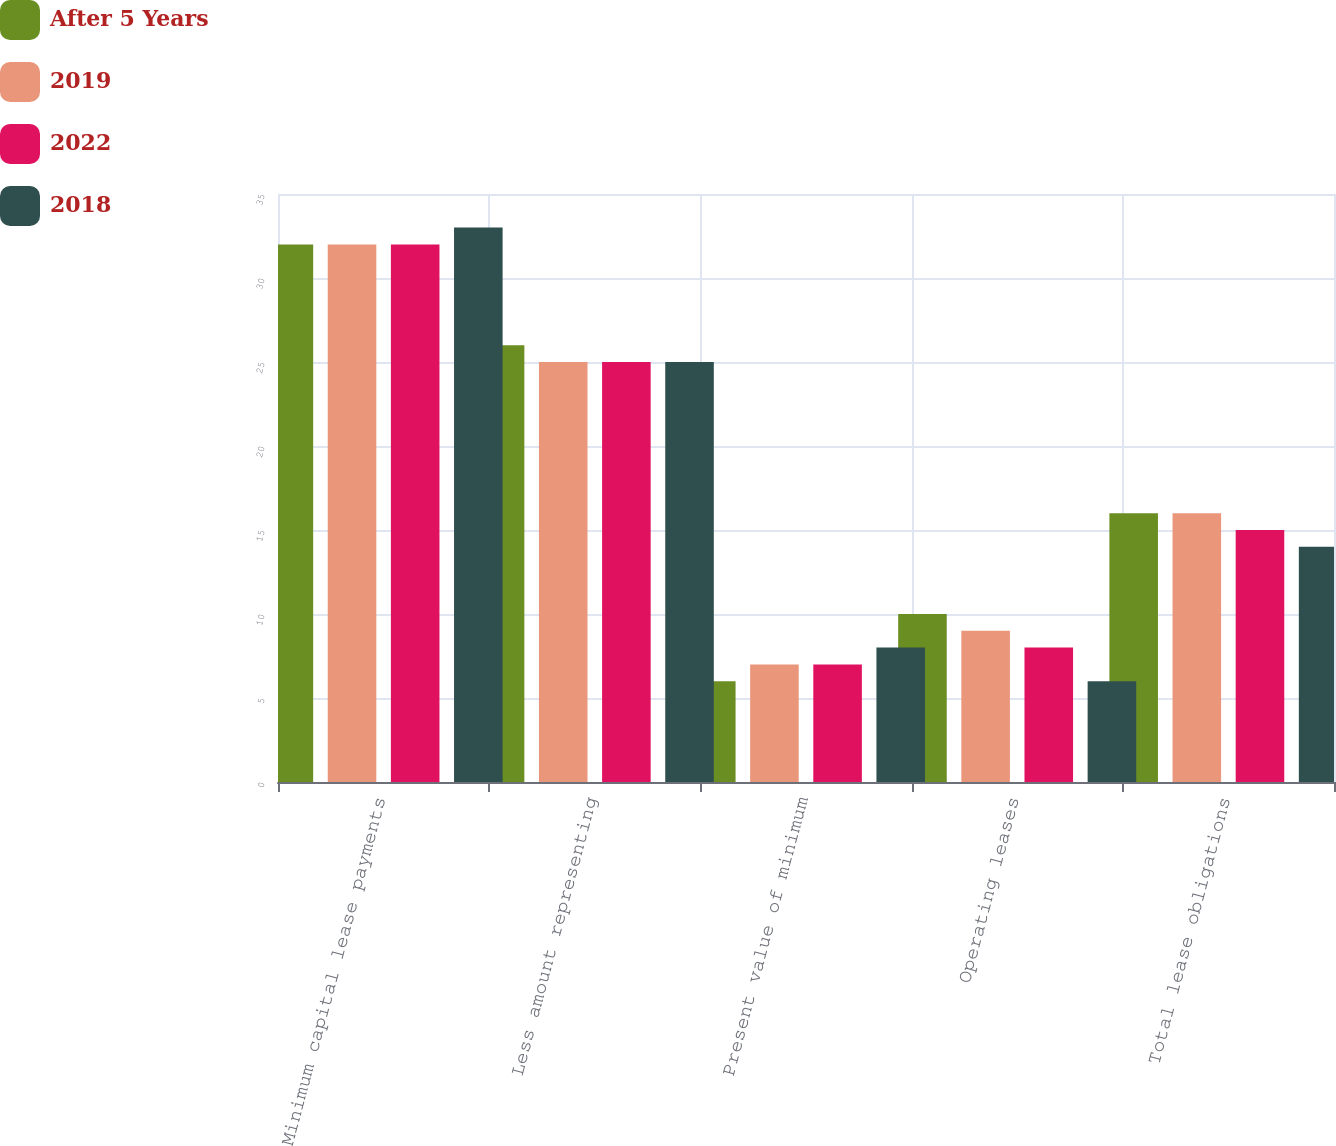Convert chart to OTSL. <chart><loc_0><loc_0><loc_500><loc_500><stacked_bar_chart><ecel><fcel>Minimum capital lease payments<fcel>Less amount representing<fcel>Present value of minimum<fcel>Operating leases<fcel>Total lease obligations<nl><fcel>After 5 Years<fcel>32<fcel>26<fcel>6<fcel>10<fcel>16<nl><fcel>2019<fcel>32<fcel>25<fcel>7<fcel>9<fcel>16<nl><fcel>2022<fcel>32<fcel>25<fcel>7<fcel>8<fcel>15<nl><fcel>2018<fcel>33<fcel>25<fcel>8<fcel>6<fcel>14<nl></chart> 